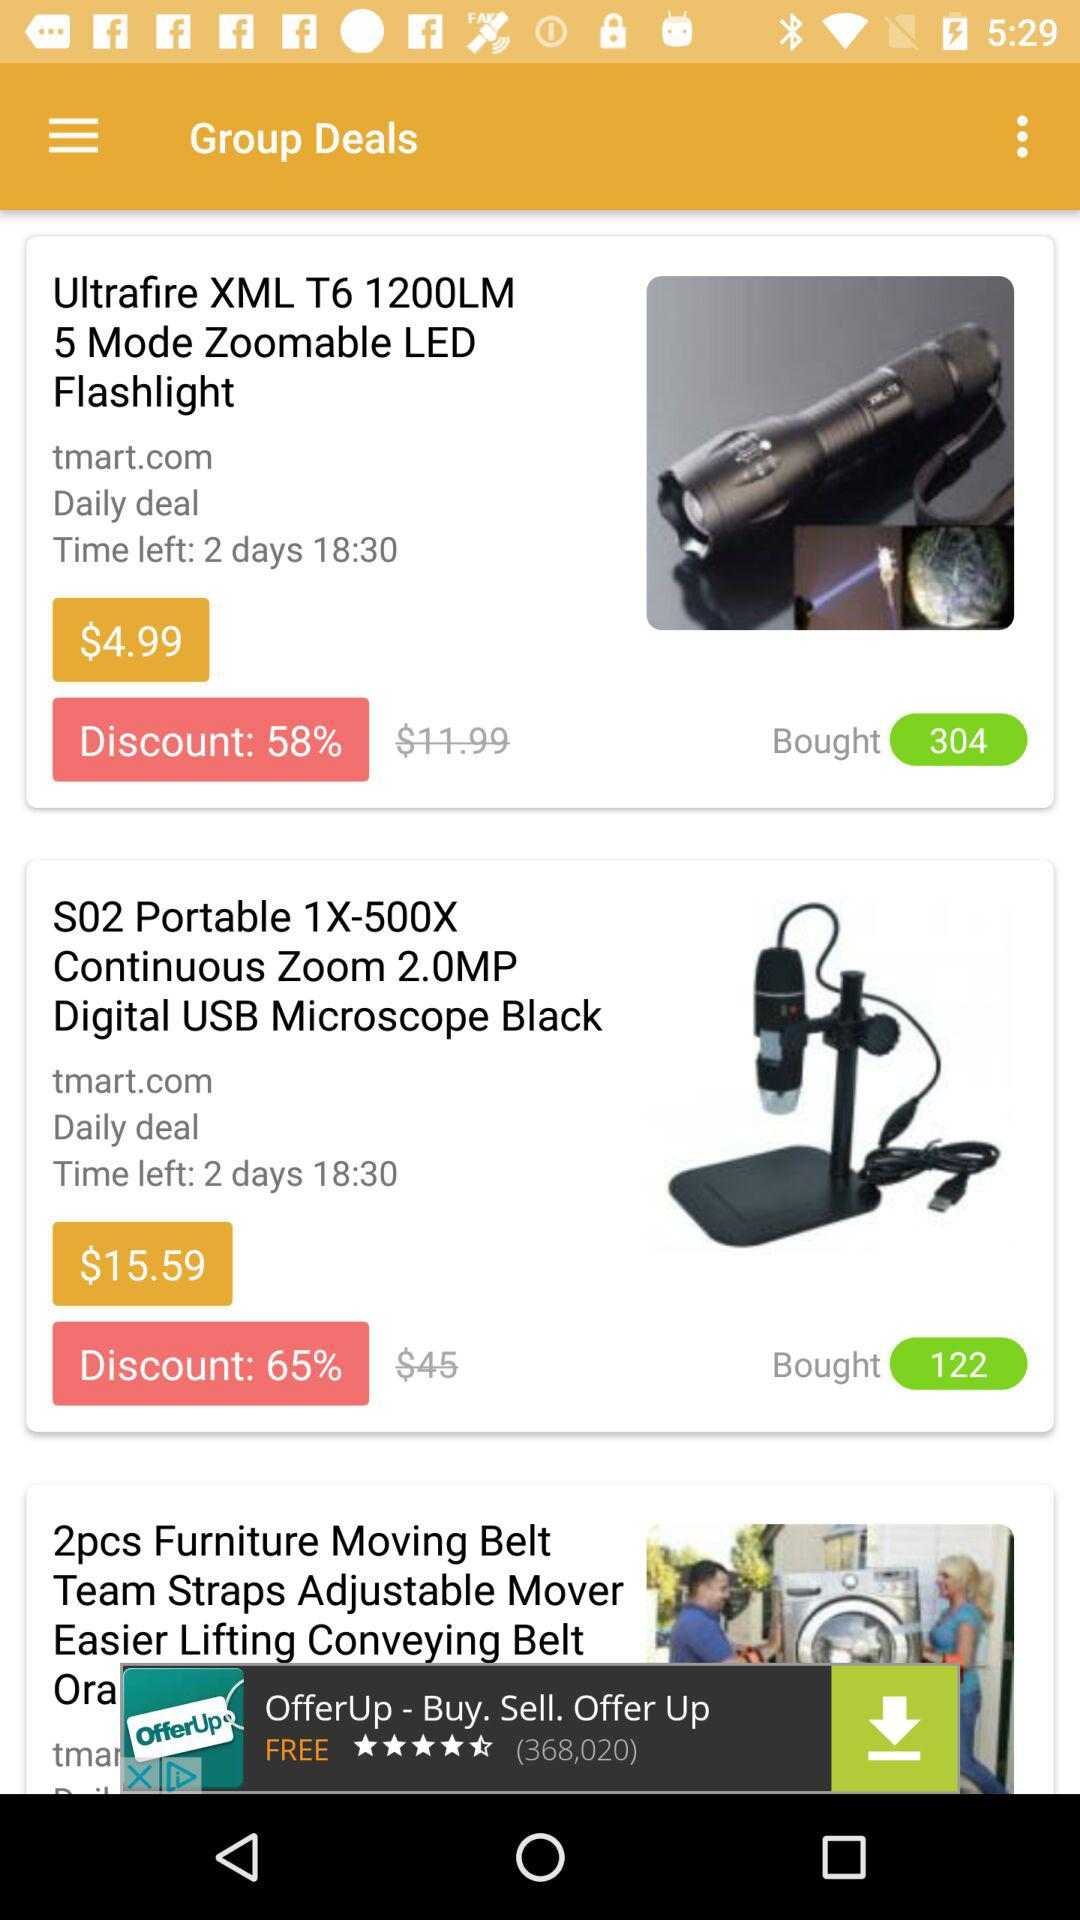What is the email address to place an order?
When the provided information is insufficient, respond with <no answer>. <no answer> 